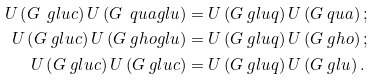<formula> <loc_0><loc_0><loc_500><loc_500>U \left ( G ^ { \ } g l u c \right ) U \left ( G ^ { \ } q u a g l u \right ) & = U \left ( G ^ { \ } g l u q \right ) U \left ( G ^ { \ } q u a \right ) ; \\ U \left ( G ^ { \ } g l u c \right ) U \left ( G ^ { \ } g h o g l u \right ) & = U \left ( G ^ { \ } g l u q \right ) U \left ( G ^ { \ } g h o \right ) ; \\ U \left ( G ^ { \ } g l u c \right ) U \left ( G ^ { \ } g l u c \right ) & = U \left ( G ^ { \ } g l u q \right ) U \left ( G ^ { \ } g l u \right ) .</formula> 